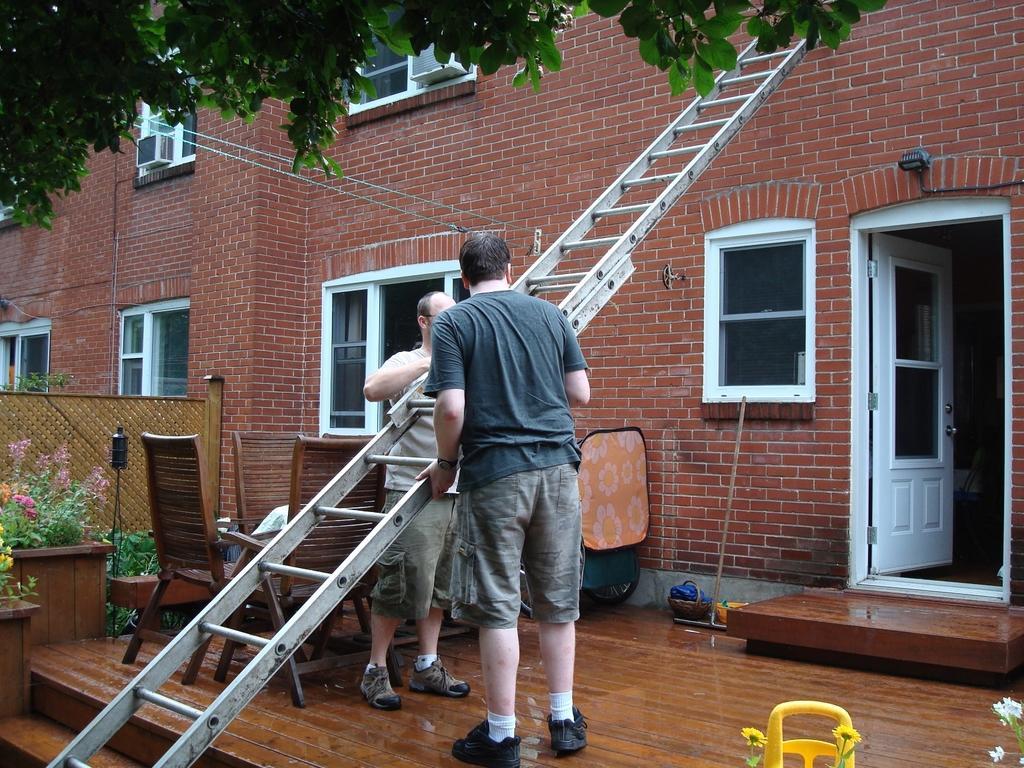How would you summarize this image in a sentence or two? In this image there are two men standing on the floor by holding the ladder. Beside them there is a building to which there are windows. On the right side there is a door. Beside the ladder there are chairs. On the left side there are flower pots. 